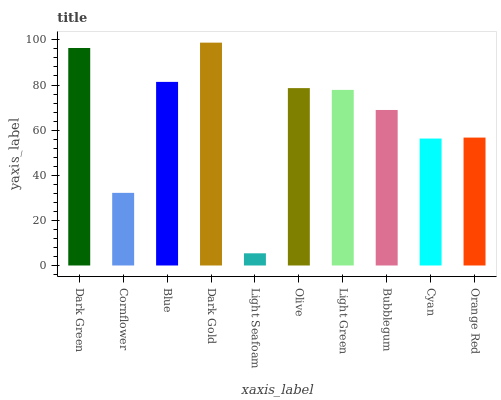Is Light Seafoam the minimum?
Answer yes or no. Yes. Is Dark Gold the maximum?
Answer yes or no. Yes. Is Cornflower the minimum?
Answer yes or no. No. Is Cornflower the maximum?
Answer yes or no. No. Is Dark Green greater than Cornflower?
Answer yes or no. Yes. Is Cornflower less than Dark Green?
Answer yes or no. Yes. Is Cornflower greater than Dark Green?
Answer yes or no. No. Is Dark Green less than Cornflower?
Answer yes or no. No. Is Light Green the high median?
Answer yes or no. Yes. Is Bubblegum the low median?
Answer yes or no. Yes. Is Light Seafoam the high median?
Answer yes or no. No. Is Cyan the low median?
Answer yes or no. No. 